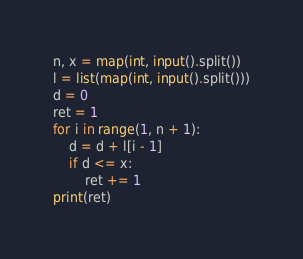Convert code to text. <code><loc_0><loc_0><loc_500><loc_500><_Python_>n, x = map(int, input().split())
l = list(map(int, input().split()))
d = 0
ret = 1
for i in range(1, n + 1):
    d = d + l[i - 1]
    if d <= x:
        ret += 1
print(ret)
</code> 